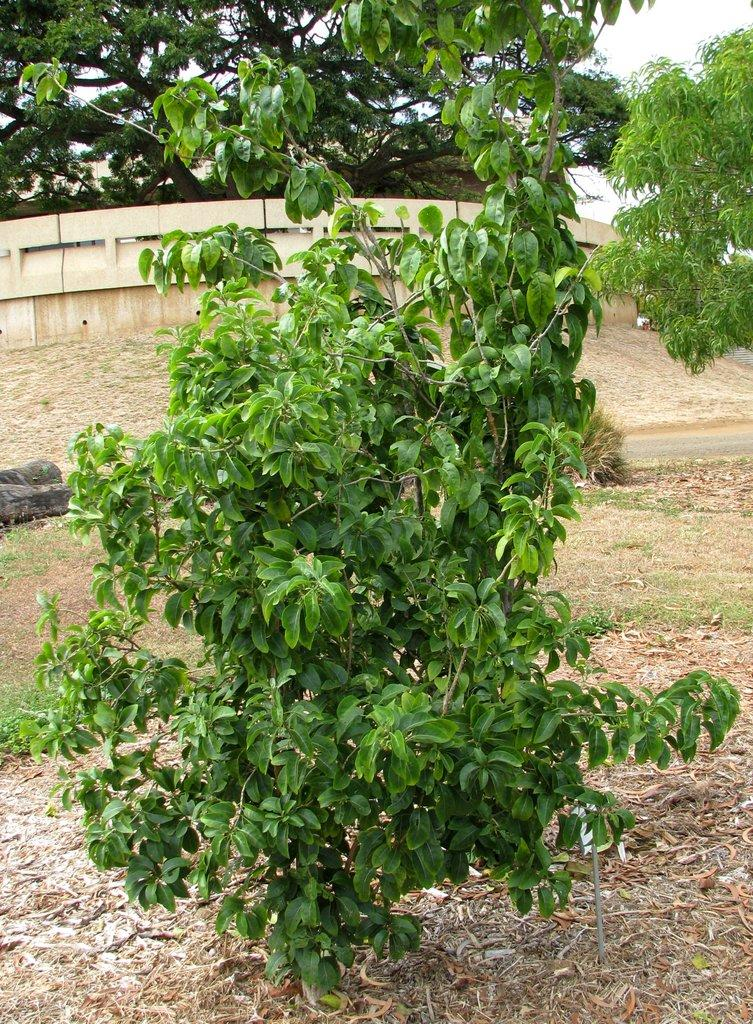What type of vegetation is present in the image? There are green trees in the image. What can be seen surrounding the trees? There is fencing in the image. What is the color of the sky in the image? The sky is white in color. Where is the library located in the image? There is no library present in the image. Is there a spy observing the trees in the image? There is no indication of a spy or any person in the image. 